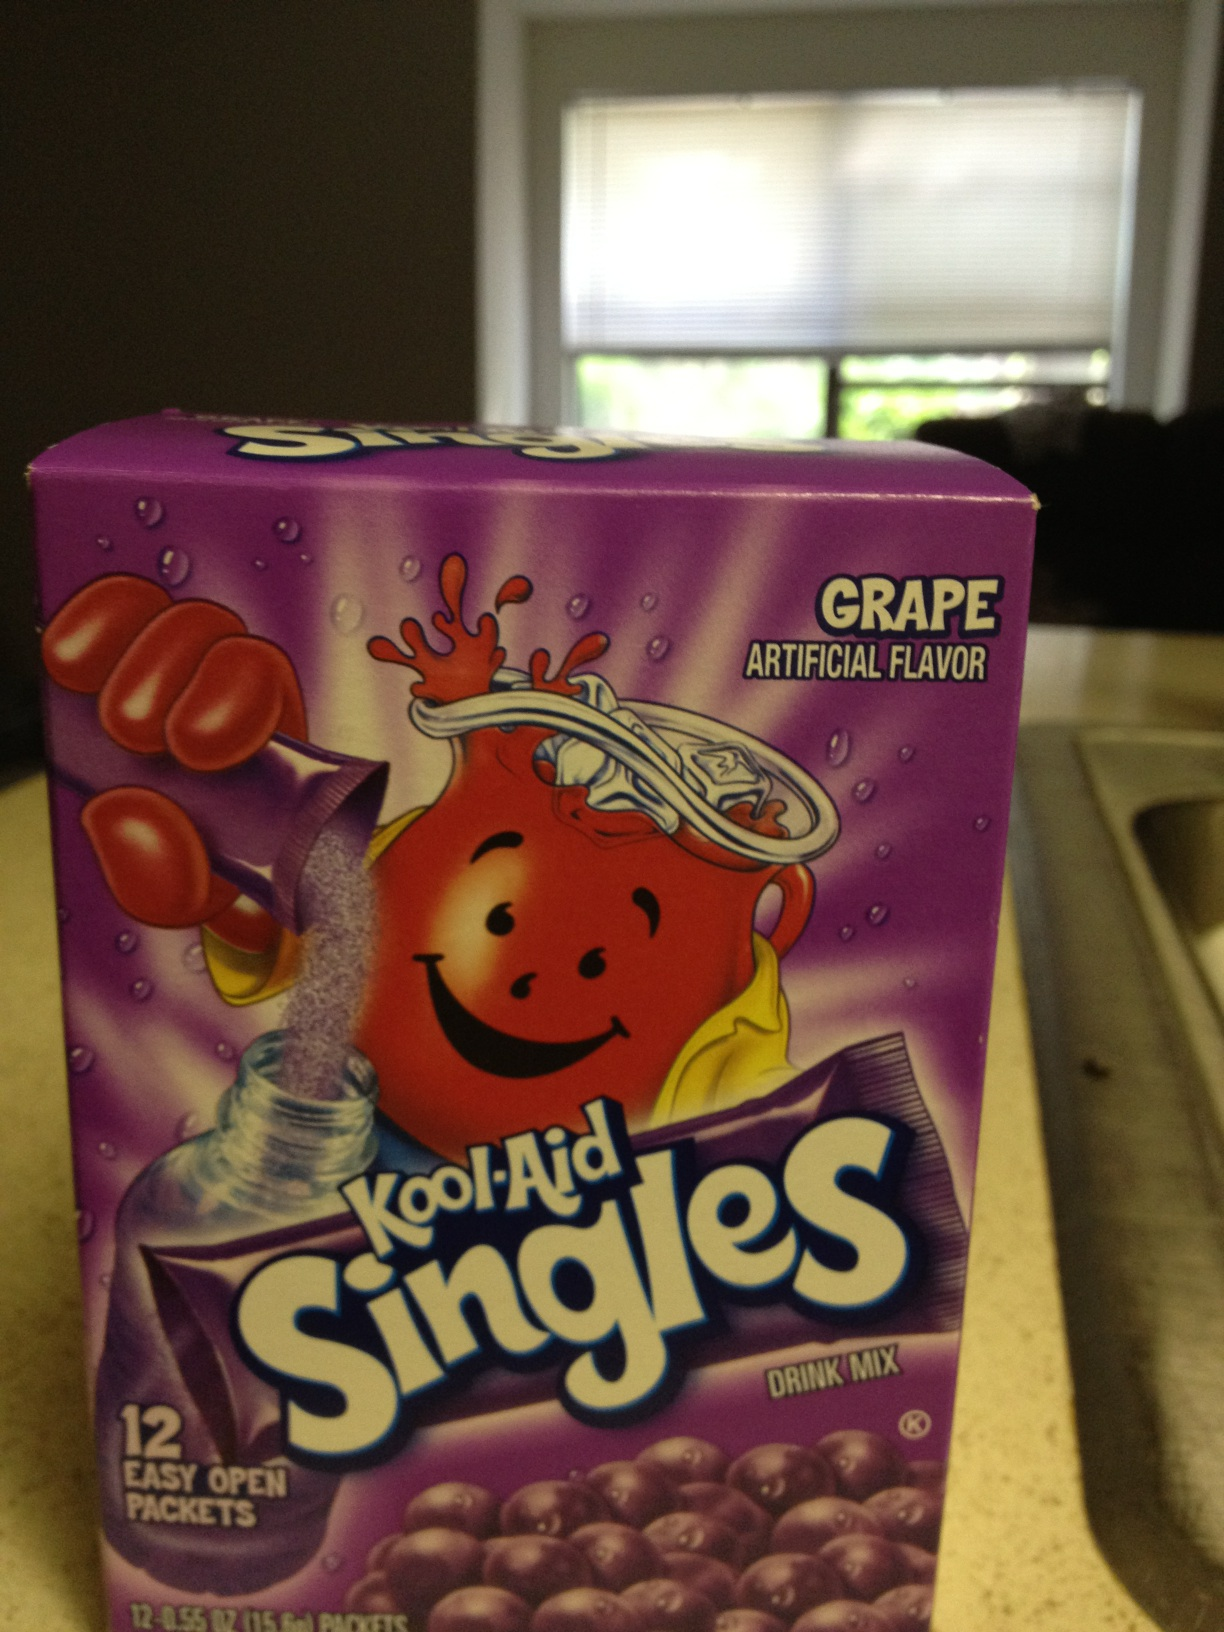Can you tell me more about what's inside this box? Inside this box, there are 12 packets of grape flavored Kool-Aid Singles. Each packet is intended to be mixed with water to create a single serving of refreshing grape flavored drink. How do you use these packets? To use a packet, simply tear it open along the easy-open edge and mix the powder with about 8 ounces of water. Stir well and enjoy a cold, delicious beverage. 